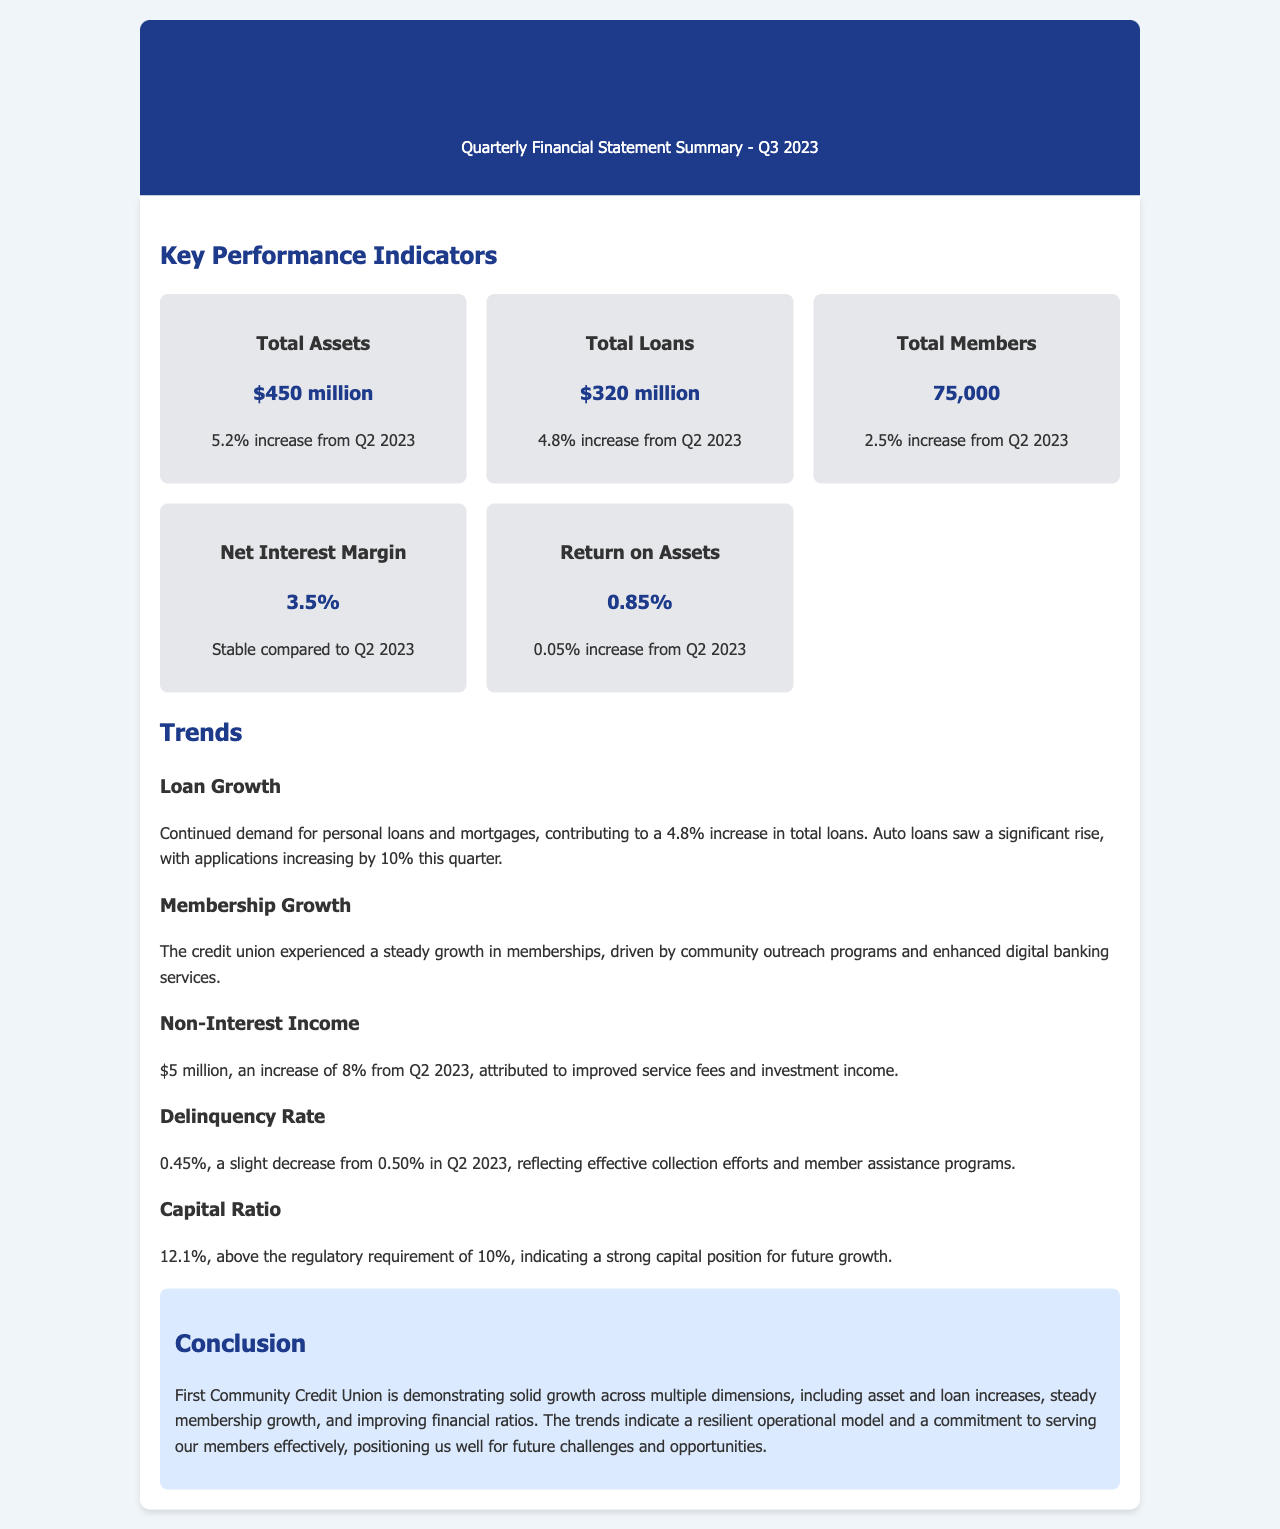What is the total assets amount? The total assets amount is explicitly stated in the document as $450 million.
Answer: $450 million What percentage increase did total loans experience from Q2 2023? The document indicates that total loans saw a 4.8% increase from Q2 2023.
Answer: 4.8% How many total members are there? The number of total members is provided as 75,000 in the document.
Answer: 75,000 What is the net interest margin for Q3 2023? The net interest margin is noted as 3.5%, which is stated as stable compared to Q2 2023.
Answer: 3.5% What contributed to the loan growth this quarter? The document explains that the demand for personal loans and mortgages, along with an increase in auto loan applications by 10%, contributed to the loan growth.
Answer: Demand for personal loans and mortgages What was the delinquency rate for Q3 2023? The document specifies the delinquency rate as 0.45%, a decrease from 0.50% in Q2 2023.
Answer: 0.45% What percentage is the capital ratio above the regulatory requirement? The capital ratio of 12.1% is noted to be above the regulatory requirement of 10%, indicating a margin of 2.1%.
Answer: 2.1% How much was non-interest income for Q3 2023? The document states that non-interest income was $5 million, which reflects an increase of 8% from Q2 2023.
Answer: $5 million What does the conclusion highlight about the credit union's performance? The conclusion emphasizes solid growth across multiple dimensions, including asset and loan increases.
Answer: Solid growth across multiple dimensions 